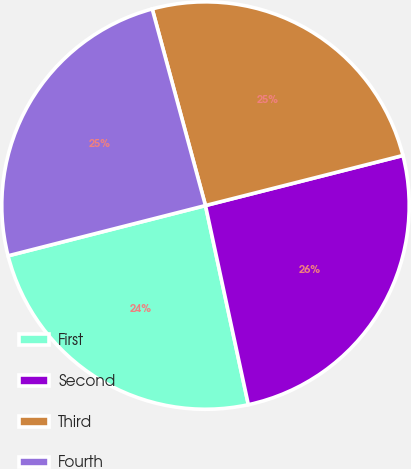Convert chart to OTSL. <chart><loc_0><loc_0><loc_500><loc_500><pie_chart><fcel>First<fcel>Second<fcel>Third<fcel>Fourth<nl><fcel>24.41%<fcel>25.58%<fcel>25.26%<fcel>24.76%<nl></chart> 